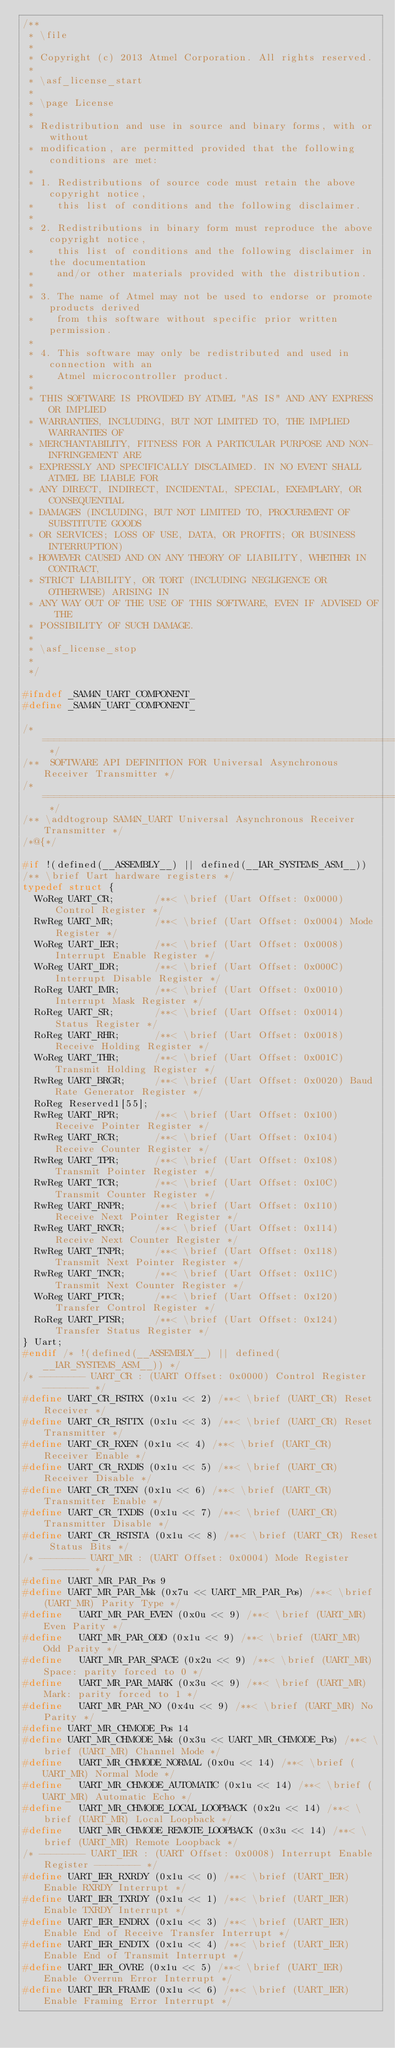<code> <loc_0><loc_0><loc_500><loc_500><_C_>/**
 * \file
 *
 * Copyright (c) 2013 Atmel Corporation. All rights reserved.
 *
 * \asf_license_start
 *
 * \page License
 *
 * Redistribution and use in source and binary forms, with or without
 * modification, are permitted provided that the following conditions are met:
 *
 * 1. Redistributions of source code must retain the above copyright notice,
 *    this list of conditions and the following disclaimer.
 *
 * 2. Redistributions in binary form must reproduce the above copyright notice,
 *    this list of conditions and the following disclaimer in the documentation
 *    and/or other materials provided with the distribution.
 *
 * 3. The name of Atmel may not be used to endorse or promote products derived
 *    from this software without specific prior written permission.
 *
 * 4. This software may only be redistributed and used in connection with an
 *    Atmel microcontroller product.
 *
 * THIS SOFTWARE IS PROVIDED BY ATMEL "AS IS" AND ANY EXPRESS OR IMPLIED
 * WARRANTIES, INCLUDING, BUT NOT LIMITED TO, THE IMPLIED WARRANTIES OF
 * MERCHANTABILITY, FITNESS FOR A PARTICULAR PURPOSE AND NON-INFRINGEMENT ARE
 * EXPRESSLY AND SPECIFICALLY DISCLAIMED. IN NO EVENT SHALL ATMEL BE LIABLE FOR
 * ANY DIRECT, INDIRECT, INCIDENTAL, SPECIAL, EXEMPLARY, OR CONSEQUENTIAL
 * DAMAGES (INCLUDING, BUT NOT LIMITED TO, PROCUREMENT OF SUBSTITUTE GOODS
 * OR SERVICES; LOSS OF USE, DATA, OR PROFITS; OR BUSINESS INTERRUPTION)
 * HOWEVER CAUSED AND ON ANY THEORY OF LIABILITY, WHETHER IN CONTRACT,
 * STRICT LIABILITY, OR TORT (INCLUDING NEGLIGENCE OR OTHERWISE) ARISING IN
 * ANY WAY OUT OF THE USE OF THIS SOFTWARE, EVEN IF ADVISED OF THE
 * POSSIBILITY OF SUCH DAMAGE.
 *
 * \asf_license_stop
 *
 */

#ifndef _SAM4N_UART_COMPONENT_
#define _SAM4N_UART_COMPONENT_

/* ============================================================================= */
/**  SOFTWARE API DEFINITION FOR Universal Asynchronous Receiver Transmitter */
/* ============================================================================= */
/** \addtogroup SAM4N_UART Universal Asynchronous Receiver Transmitter */
/*@{*/

#if !(defined(__ASSEMBLY__) || defined(__IAR_SYSTEMS_ASM__))
/** \brief Uart hardware registers */
typedef struct {
  WoReg UART_CR;       /**< \brief (Uart Offset: 0x0000) Control Register */
  RwReg UART_MR;       /**< \brief (Uart Offset: 0x0004) Mode Register */
  WoReg UART_IER;      /**< \brief (Uart Offset: 0x0008) Interrupt Enable Register */
  WoReg UART_IDR;      /**< \brief (Uart Offset: 0x000C) Interrupt Disable Register */
  RoReg UART_IMR;      /**< \brief (Uart Offset: 0x0010) Interrupt Mask Register */
  RoReg UART_SR;       /**< \brief (Uart Offset: 0x0014) Status Register */
  RoReg UART_RHR;      /**< \brief (Uart Offset: 0x0018) Receive Holding Register */
  WoReg UART_THR;      /**< \brief (Uart Offset: 0x001C) Transmit Holding Register */
  RwReg UART_BRGR;     /**< \brief (Uart Offset: 0x0020) Baud Rate Generator Register */
  RoReg Reserved1[55];
  RwReg UART_RPR;      /**< \brief (Uart Offset: 0x100) Receive Pointer Register */
  RwReg UART_RCR;      /**< \brief (Uart Offset: 0x104) Receive Counter Register */
  RwReg UART_TPR;      /**< \brief (Uart Offset: 0x108) Transmit Pointer Register */
  RwReg UART_TCR;      /**< \brief (Uart Offset: 0x10C) Transmit Counter Register */
  RwReg UART_RNPR;     /**< \brief (Uart Offset: 0x110) Receive Next Pointer Register */
  RwReg UART_RNCR;     /**< \brief (Uart Offset: 0x114) Receive Next Counter Register */
  RwReg UART_TNPR;     /**< \brief (Uart Offset: 0x118) Transmit Next Pointer Register */
  RwReg UART_TNCR;     /**< \brief (Uart Offset: 0x11C) Transmit Next Counter Register */
  WoReg UART_PTCR;     /**< \brief (Uart Offset: 0x120) Transfer Control Register */
  RoReg UART_PTSR;     /**< \brief (Uart Offset: 0x124) Transfer Status Register */
} Uart;
#endif /* !(defined(__ASSEMBLY__) || defined(__IAR_SYSTEMS_ASM__)) */
/* -------- UART_CR : (UART Offset: 0x0000) Control Register -------- */
#define UART_CR_RSTRX (0x1u << 2) /**< \brief (UART_CR) Reset Receiver */
#define UART_CR_RSTTX (0x1u << 3) /**< \brief (UART_CR) Reset Transmitter */
#define UART_CR_RXEN (0x1u << 4) /**< \brief (UART_CR) Receiver Enable */
#define UART_CR_RXDIS (0x1u << 5) /**< \brief (UART_CR) Receiver Disable */
#define UART_CR_TXEN (0x1u << 6) /**< \brief (UART_CR) Transmitter Enable */
#define UART_CR_TXDIS (0x1u << 7) /**< \brief (UART_CR) Transmitter Disable */
#define UART_CR_RSTSTA (0x1u << 8) /**< \brief (UART_CR) Reset Status Bits */
/* -------- UART_MR : (UART Offset: 0x0004) Mode Register -------- */
#define UART_MR_PAR_Pos 9
#define UART_MR_PAR_Msk (0x7u << UART_MR_PAR_Pos) /**< \brief (UART_MR) Parity Type */
#define   UART_MR_PAR_EVEN (0x0u << 9) /**< \brief (UART_MR) Even Parity */
#define   UART_MR_PAR_ODD (0x1u << 9) /**< \brief (UART_MR) Odd Parity */
#define   UART_MR_PAR_SPACE (0x2u << 9) /**< \brief (UART_MR) Space: parity forced to 0 */
#define   UART_MR_PAR_MARK (0x3u << 9) /**< \brief (UART_MR) Mark: parity forced to 1 */
#define   UART_MR_PAR_NO (0x4u << 9) /**< \brief (UART_MR) No Parity */
#define UART_MR_CHMODE_Pos 14
#define UART_MR_CHMODE_Msk (0x3u << UART_MR_CHMODE_Pos) /**< \brief (UART_MR) Channel Mode */
#define   UART_MR_CHMODE_NORMAL (0x0u << 14) /**< \brief (UART_MR) Normal Mode */
#define   UART_MR_CHMODE_AUTOMATIC (0x1u << 14) /**< \brief (UART_MR) Automatic Echo */
#define   UART_MR_CHMODE_LOCAL_LOOPBACK (0x2u << 14) /**< \brief (UART_MR) Local Loopback */
#define   UART_MR_CHMODE_REMOTE_LOOPBACK (0x3u << 14) /**< \brief (UART_MR) Remote Loopback */
/* -------- UART_IER : (UART Offset: 0x0008) Interrupt Enable Register -------- */
#define UART_IER_RXRDY (0x1u << 0) /**< \brief (UART_IER) Enable RXRDY Interrupt */
#define UART_IER_TXRDY (0x1u << 1) /**< \brief (UART_IER) Enable TXRDY Interrupt */
#define UART_IER_ENDRX (0x1u << 3) /**< \brief (UART_IER) Enable End of Receive Transfer Interrupt */
#define UART_IER_ENDTX (0x1u << 4) /**< \brief (UART_IER) Enable End of Transmit Interrupt */
#define UART_IER_OVRE (0x1u << 5) /**< \brief (UART_IER) Enable Overrun Error Interrupt */
#define UART_IER_FRAME (0x1u << 6) /**< \brief (UART_IER) Enable Framing Error Interrupt */</code> 